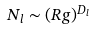<formula> <loc_0><loc_0><loc_500><loc_500>N _ { l } \sim ( R g ) ^ { D _ { l } }</formula> 